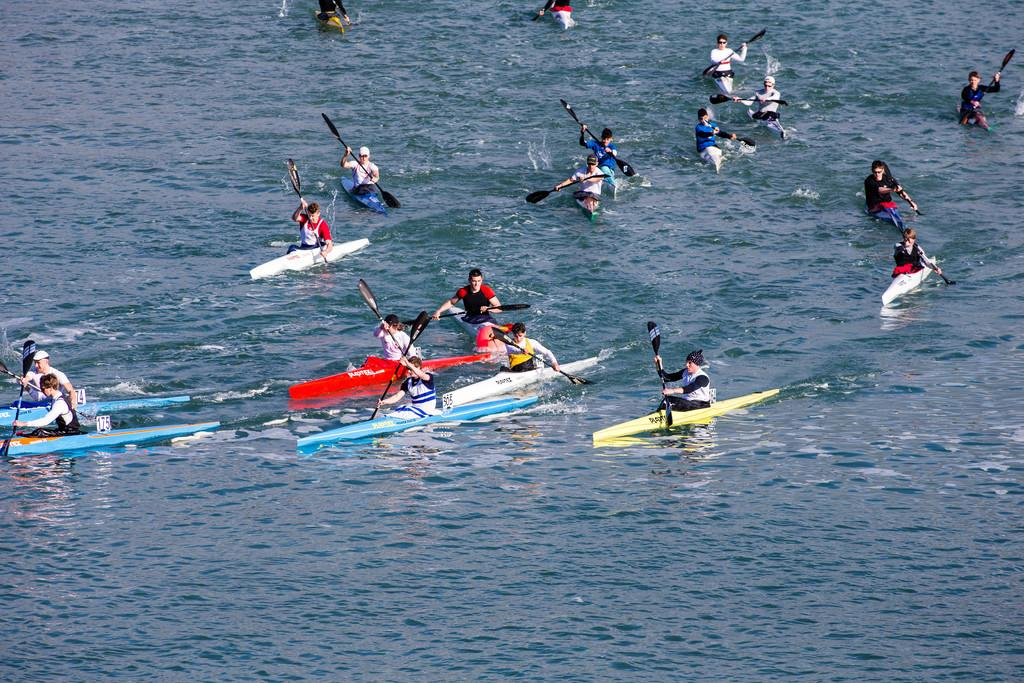Who is present in the image? There are people in the image. What are the people doing in the image? The people are sailing a boat. Where is the boat located in the image? The boat is on the water. What are the people using to propel the boat? The people are holding paddles. What type of badge can be seen on the boat in the image? There is no badge present on the boat in the image. What liquid is visible in the image? The only liquid mentioned in the facts is water, which is where the boat is located. There is no other liquid visible in the image. 